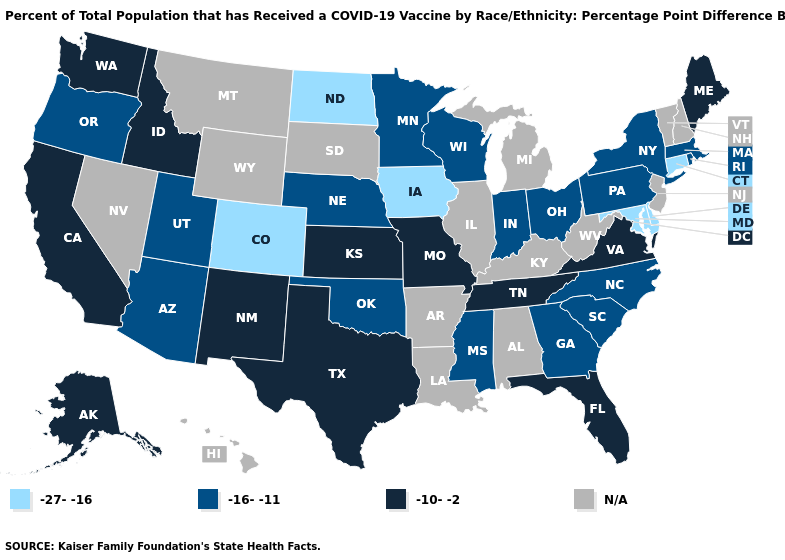What is the value of Nevada?
Keep it brief. N/A. What is the value of Vermont?
Keep it brief. N/A. What is the value of West Virginia?
Answer briefly. N/A. What is the value of Wisconsin?
Answer briefly. -16--11. How many symbols are there in the legend?
Quick response, please. 4. What is the value of Alaska?
Quick response, please. -10--2. Does Tennessee have the highest value in the USA?
Concise answer only. Yes. Does Ohio have the highest value in the MidWest?
Quick response, please. No. Does North Dakota have the lowest value in the MidWest?
Answer briefly. Yes. What is the value of Connecticut?
Give a very brief answer. -27--16. Among the states that border South Dakota , does North Dakota have the highest value?
Write a very short answer. No. Name the states that have a value in the range -27--16?
Keep it brief. Colorado, Connecticut, Delaware, Iowa, Maryland, North Dakota. How many symbols are there in the legend?
Give a very brief answer. 4. Does the map have missing data?
Concise answer only. Yes. 